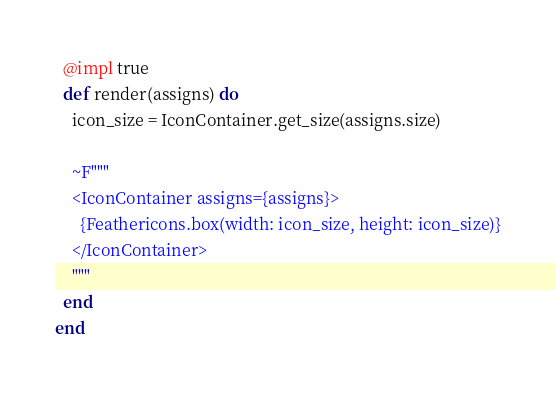<code> <loc_0><loc_0><loc_500><loc_500><_Elixir_>  @impl true
  def render(assigns) do
    icon_size = IconContainer.get_size(assigns.size)

    ~F"""
    <IconContainer assigns={assigns}>
      {Feathericons.box(width: icon_size, height: icon_size)}
    </IconContainer>
    """
  end
end
</code> 